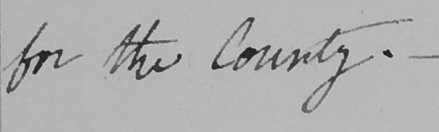What does this handwritten line say? for the County . _ 